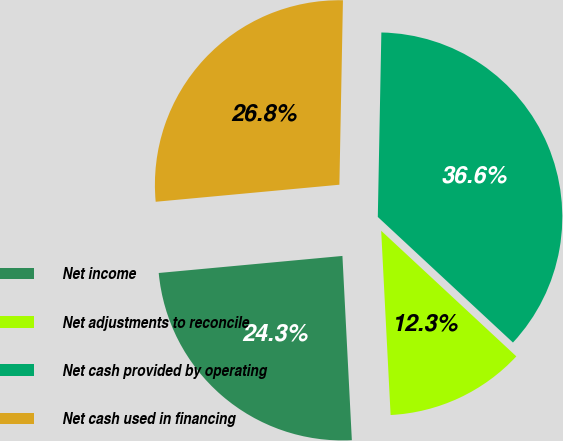Convert chart. <chart><loc_0><loc_0><loc_500><loc_500><pie_chart><fcel>Net income<fcel>Net adjustments to reconcile<fcel>Net cash provided by operating<fcel>Net cash used in financing<nl><fcel>24.34%<fcel>12.27%<fcel>36.61%<fcel>26.78%<nl></chart> 